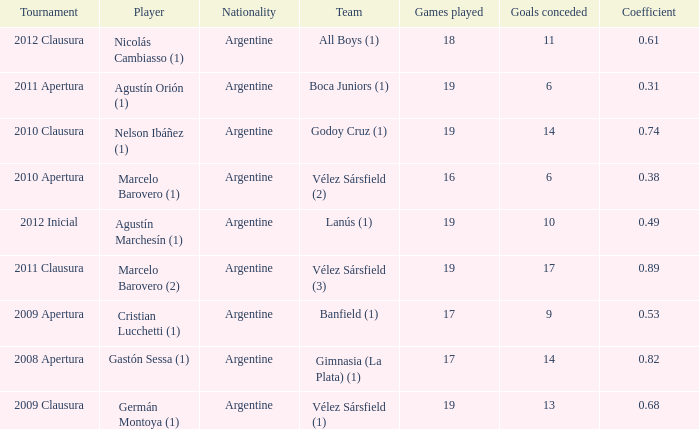Which team was in the 2012 clausura tournament? All Boys (1). 